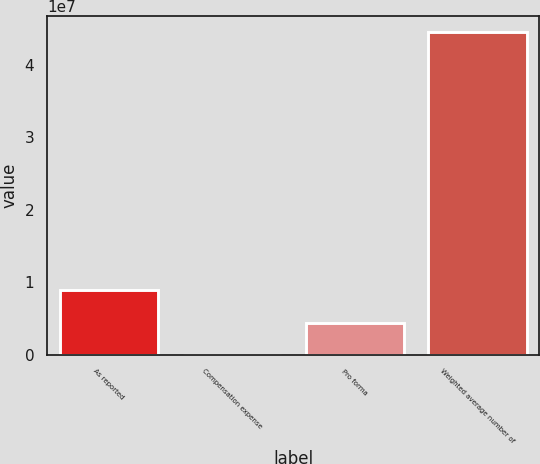<chart> <loc_0><loc_0><loc_500><loc_500><bar_chart><fcel>As reported<fcel>Compensation expense<fcel>Pro forma<fcel>Weighted average number of<nl><fcel>8.90018e+06<fcel>6748<fcel>4.45346e+06<fcel>4.44739e+07<nl></chart> 